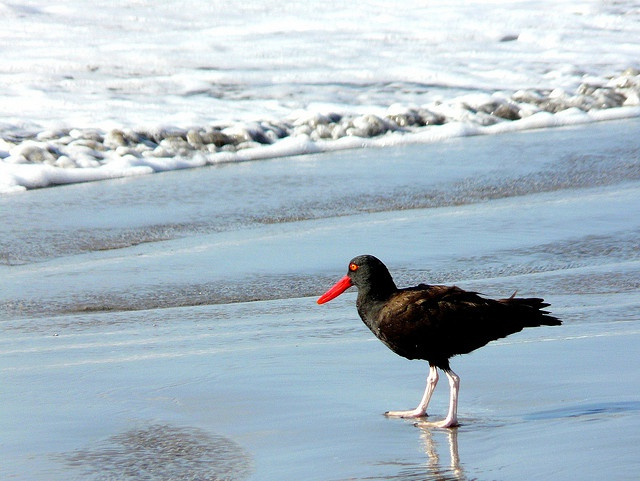Describe the objects in this image and their specific colors. I can see a bird in white, black, gray, ivory, and maroon tones in this image. 